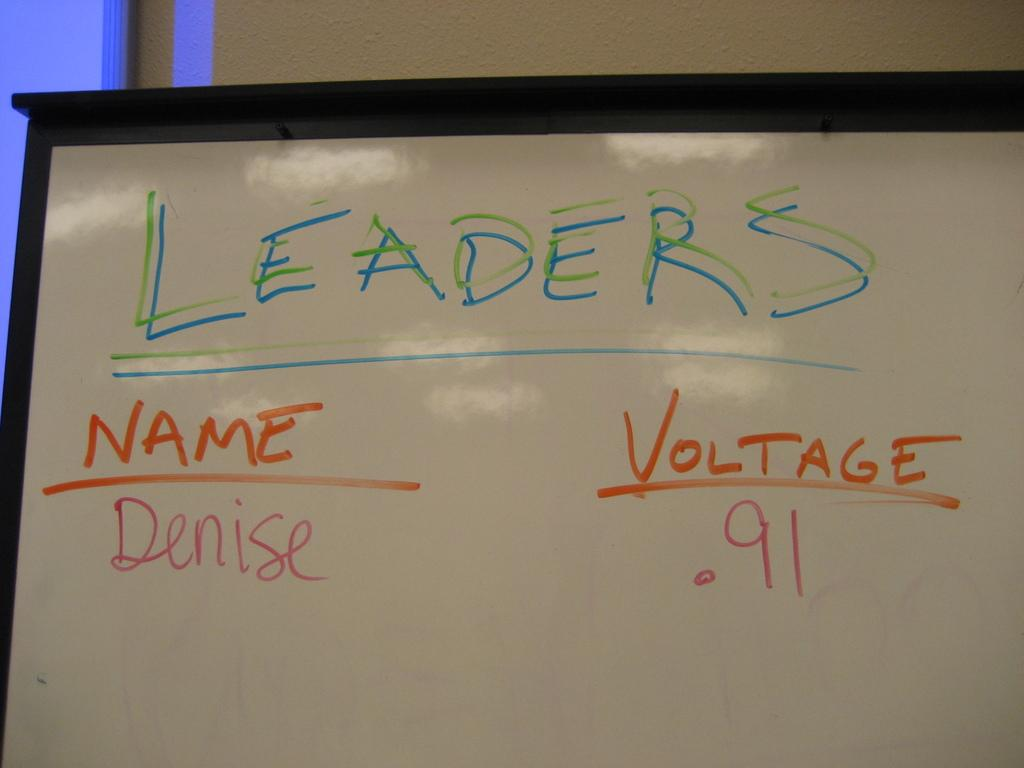<image>
Share a concise interpretation of the image provided. A whiteboard with writing on it labelled Leaders. 